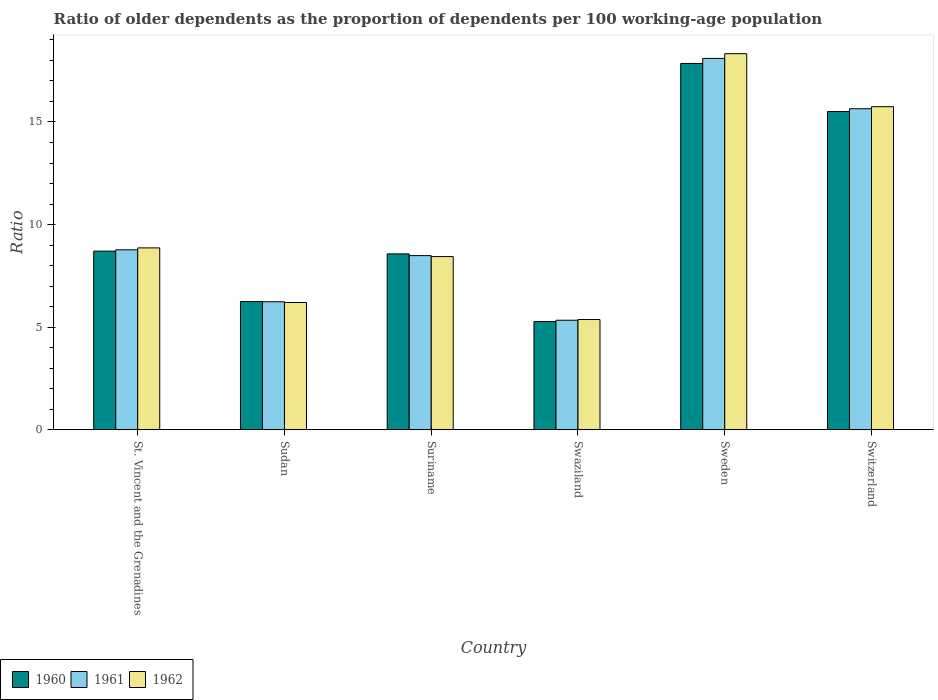Are the number of bars on each tick of the X-axis equal?
Provide a short and direct response. Yes. How many bars are there on the 1st tick from the right?
Your answer should be very brief. 3. What is the label of the 1st group of bars from the left?
Provide a short and direct response. St. Vincent and the Grenadines. In how many cases, is the number of bars for a given country not equal to the number of legend labels?
Make the answer very short. 0. What is the age dependency ratio(old) in 1960 in Suriname?
Your response must be concise. 8.57. Across all countries, what is the maximum age dependency ratio(old) in 1960?
Ensure brevity in your answer.  17.85. Across all countries, what is the minimum age dependency ratio(old) in 1962?
Keep it short and to the point. 5.37. In which country was the age dependency ratio(old) in 1960 minimum?
Your answer should be compact. Swaziland. What is the total age dependency ratio(old) in 1960 in the graph?
Your answer should be very brief. 62.16. What is the difference between the age dependency ratio(old) in 1961 in Suriname and that in Sweden?
Give a very brief answer. -9.61. What is the difference between the age dependency ratio(old) in 1962 in Suriname and the age dependency ratio(old) in 1960 in St. Vincent and the Grenadines?
Provide a succinct answer. -0.27. What is the average age dependency ratio(old) in 1962 per country?
Provide a succinct answer. 10.49. What is the difference between the age dependency ratio(old) of/in 1961 and age dependency ratio(old) of/in 1962 in Sweden?
Offer a very short reply. -0.23. In how many countries, is the age dependency ratio(old) in 1962 greater than 9?
Provide a short and direct response. 2. What is the ratio of the age dependency ratio(old) in 1960 in St. Vincent and the Grenadines to that in Switzerland?
Keep it short and to the point. 0.56. Is the difference between the age dependency ratio(old) in 1961 in St. Vincent and the Grenadines and Sweden greater than the difference between the age dependency ratio(old) in 1962 in St. Vincent and the Grenadines and Sweden?
Give a very brief answer. Yes. What is the difference between the highest and the second highest age dependency ratio(old) in 1962?
Provide a short and direct response. -9.46. What is the difference between the highest and the lowest age dependency ratio(old) in 1960?
Keep it short and to the point. 12.58. Is the sum of the age dependency ratio(old) in 1961 in Sudan and Suriname greater than the maximum age dependency ratio(old) in 1962 across all countries?
Make the answer very short. No. Are all the bars in the graph horizontal?
Your answer should be compact. No. Are the values on the major ticks of Y-axis written in scientific E-notation?
Give a very brief answer. No. Does the graph contain any zero values?
Your answer should be very brief. No. Where does the legend appear in the graph?
Give a very brief answer. Bottom left. How are the legend labels stacked?
Your response must be concise. Horizontal. What is the title of the graph?
Make the answer very short. Ratio of older dependents as the proportion of dependents per 100 working-age population. Does "1977" appear as one of the legend labels in the graph?
Make the answer very short. No. What is the label or title of the Y-axis?
Offer a terse response. Ratio. What is the Ratio of 1960 in St. Vincent and the Grenadines?
Your response must be concise. 8.71. What is the Ratio of 1961 in St. Vincent and the Grenadines?
Keep it short and to the point. 8.77. What is the Ratio of 1962 in St. Vincent and the Grenadines?
Give a very brief answer. 8.86. What is the Ratio of 1960 in Sudan?
Give a very brief answer. 6.25. What is the Ratio of 1961 in Sudan?
Keep it short and to the point. 6.24. What is the Ratio of 1962 in Sudan?
Your answer should be compact. 6.2. What is the Ratio of 1960 in Suriname?
Your answer should be very brief. 8.57. What is the Ratio of 1961 in Suriname?
Offer a very short reply. 8.49. What is the Ratio in 1962 in Suriname?
Make the answer very short. 8.44. What is the Ratio in 1960 in Swaziland?
Keep it short and to the point. 5.28. What is the Ratio of 1961 in Swaziland?
Provide a short and direct response. 5.34. What is the Ratio of 1962 in Swaziland?
Your answer should be compact. 5.37. What is the Ratio in 1960 in Sweden?
Keep it short and to the point. 17.85. What is the Ratio of 1961 in Sweden?
Ensure brevity in your answer.  18.1. What is the Ratio of 1962 in Sweden?
Provide a succinct answer. 18.33. What is the Ratio of 1960 in Switzerland?
Offer a terse response. 15.51. What is the Ratio in 1961 in Switzerland?
Give a very brief answer. 15.64. What is the Ratio of 1962 in Switzerland?
Offer a terse response. 15.74. Across all countries, what is the maximum Ratio of 1960?
Your answer should be compact. 17.85. Across all countries, what is the maximum Ratio of 1961?
Offer a terse response. 18.1. Across all countries, what is the maximum Ratio of 1962?
Your answer should be compact. 18.33. Across all countries, what is the minimum Ratio in 1960?
Provide a short and direct response. 5.28. Across all countries, what is the minimum Ratio in 1961?
Make the answer very short. 5.34. Across all countries, what is the minimum Ratio in 1962?
Your response must be concise. 5.37. What is the total Ratio of 1960 in the graph?
Your answer should be compact. 62.16. What is the total Ratio in 1961 in the graph?
Your answer should be compact. 62.58. What is the total Ratio in 1962 in the graph?
Your response must be concise. 62.95. What is the difference between the Ratio of 1960 in St. Vincent and the Grenadines and that in Sudan?
Provide a succinct answer. 2.46. What is the difference between the Ratio in 1961 in St. Vincent and the Grenadines and that in Sudan?
Your answer should be compact. 2.53. What is the difference between the Ratio in 1962 in St. Vincent and the Grenadines and that in Sudan?
Offer a very short reply. 2.66. What is the difference between the Ratio of 1960 in St. Vincent and the Grenadines and that in Suriname?
Your response must be concise. 0.14. What is the difference between the Ratio in 1961 in St. Vincent and the Grenadines and that in Suriname?
Offer a terse response. 0.28. What is the difference between the Ratio in 1962 in St. Vincent and the Grenadines and that in Suriname?
Provide a short and direct response. 0.42. What is the difference between the Ratio in 1960 in St. Vincent and the Grenadines and that in Swaziland?
Your answer should be very brief. 3.43. What is the difference between the Ratio of 1961 in St. Vincent and the Grenadines and that in Swaziland?
Provide a succinct answer. 3.43. What is the difference between the Ratio of 1962 in St. Vincent and the Grenadines and that in Swaziland?
Provide a succinct answer. 3.49. What is the difference between the Ratio of 1960 in St. Vincent and the Grenadines and that in Sweden?
Offer a very short reply. -9.14. What is the difference between the Ratio in 1961 in St. Vincent and the Grenadines and that in Sweden?
Your answer should be compact. -9.33. What is the difference between the Ratio in 1962 in St. Vincent and the Grenadines and that in Sweden?
Keep it short and to the point. -9.46. What is the difference between the Ratio in 1960 in St. Vincent and the Grenadines and that in Switzerland?
Your response must be concise. -6.8. What is the difference between the Ratio of 1961 in St. Vincent and the Grenadines and that in Switzerland?
Offer a terse response. -6.87. What is the difference between the Ratio of 1962 in St. Vincent and the Grenadines and that in Switzerland?
Give a very brief answer. -6.88. What is the difference between the Ratio of 1960 in Sudan and that in Suriname?
Ensure brevity in your answer.  -2.32. What is the difference between the Ratio of 1961 in Sudan and that in Suriname?
Your answer should be very brief. -2.25. What is the difference between the Ratio of 1962 in Sudan and that in Suriname?
Offer a very short reply. -2.24. What is the difference between the Ratio in 1960 in Sudan and that in Swaziland?
Provide a succinct answer. 0.97. What is the difference between the Ratio in 1961 in Sudan and that in Swaziland?
Make the answer very short. 0.9. What is the difference between the Ratio of 1962 in Sudan and that in Swaziland?
Offer a very short reply. 0.83. What is the difference between the Ratio in 1960 in Sudan and that in Sweden?
Your response must be concise. -11.6. What is the difference between the Ratio in 1961 in Sudan and that in Sweden?
Provide a short and direct response. -11.86. What is the difference between the Ratio in 1962 in Sudan and that in Sweden?
Provide a succinct answer. -12.12. What is the difference between the Ratio of 1960 in Sudan and that in Switzerland?
Provide a succinct answer. -9.26. What is the difference between the Ratio of 1961 in Sudan and that in Switzerland?
Your answer should be very brief. -9.41. What is the difference between the Ratio of 1962 in Sudan and that in Switzerland?
Offer a very short reply. -9.54. What is the difference between the Ratio in 1960 in Suriname and that in Swaziland?
Ensure brevity in your answer.  3.3. What is the difference between the Ratio of 1961 in Suriname and that in Swaziland?
Your response must be concise. 3.15. What is the difference between the Ratio in 1962 in Suriname and that in Swaziland?
Make the answer very short. 3.07. What is the difference between the Ratio of 1960 in Suriname and that in Sweden?
Offer a terse response. -9.28. What is the difference between the Ratio in 1961 in Suriname and that in Sweden?
Ensure brevity in your answer.  -9.61. What is the difference between the Ratio of 1962 in Suriname and that in Sweden?
Give a very brief answer. -9.89. What is the difference between the Ratio of 1960 in Suriname and that in Switzerland?
Provide a succinct answer. -6.94. What is the difference between the Ratio of 1961 in Suriname and that in Switzerland?
Give a very brief answer. -7.16. What is the difference between the Ratio of 1962 in Suriname and that in Switzerland?
Make the answer very short. -7.3. What is the difference between the Ratio of 1960 in Swaziland and that in Sweden?
Make the answer very short. -12.58. What is the difference between the Ratio of 1961 in Swaziland and that in Sweden?
Give a very brief answer. -12.76. What is the difference between the Ratio in 1962 in Swaziland and that in Sweden?
Offer a terse response. -12.95. What is the difference between the Ratio of 1960 in Swaziland and that in Switzerland?
Give a very brief answer. -10.23. What is the difference between the Ratio in 1961 in Swaziland and that in Switzerland?
Ensure brevity in your answer.  -10.31. What is the difference between the Ratio in 1962 in Swaziland and that in Switzerland?
Your response must be concise. -10.37. What is the difference between the Ratio in 1960 in Sweden and that in Switzerland?
Provide a succinct answer. 2.34. What is the difference between the Ratio of 1961 in Sweden and that in Switzerland?
Provide a short and direct response. 2.45. What is the difference between the Ratio of 1962 in Sweden and that in Switzerland?
Provide a succinct answer. 2.58. What is the difference between the Ratio of 1960 in St. Vincent and the Grenadines and the Ratio of 1961 in Sudan?
Make the answer very short. 2.47. What is the difference between the Ratio of 1960 in St. Vincent and the Grenadines and the Ratio of 1962 in Sudan?
Give a very brief answer. 2.5. What is the difference between the Ratio in 1961 in St. Vincent and the Grenadines and the Ratio in 1962 in Sudan?
Offer a very short reply. 2.57. What is the difference between the Ratio of 1960 in St. Vincent and the Grenadines and the Ratio of 1961 in Suriname?
Provide a short and direct response. 0.22. What is the difference between the Ratio in 1960 in St. Vincent and the Grenadines and the Ratio in 1962 in Suriname?
Keep it short and to the point. 0.27. What is the difference between the Ratio of 1961 in St. Vincent and the Grenadines and the Ratio of 1962 in Suriname?
Ensure brevity in your answer.  0.33. What is the difference between the Ratio of 1960 in St. Vincent and the Grenadines and the Ratio of 1961 in Swaziland?
Keep it short and to the point. 3.37. What is the difference between the Ratio of 1960 in St. Vincent and the Grenadines and the Ratio of 1962 in Swaziland?
Provide a succinct answer. 3.33. What is the difference between the Ratio in 1961 in St. Vincent and the Grenadines and the Ratio in 1962 in Swaziland?
Give a very brief answer. 3.4. What is the difference between the Ratio in 1960 in St. Vincent and the Grenadines and the Ratio in 1961 in Sweden?
Your answer should be very brief. -9.39. What is the difference between the Ratio of 1960 in St. Vincent and the Grenadines and the Ratio of 1962 in Sweden?
Provide a succinct answer. -9.62. What is the difference between the Ratio in 1961 in St. Vincent and the Grenadines and the Ratio in 1962 in Sweden?
Keep it short and to the point. -9.56. What is the difference between the Ratio in 1960 in St. Vincent and the Grenadines and the Ratio in 1961 in Switzerland?
Your response must be concise. -6.94. What is the difference between the Ratio of 1960 in St. Vincent and the Grenadines and the Ratio of 1962 in Switzerland?
Ensure brevity in your answer.  -7.04. What is the difference between the Ratio of 1961 in St. Vincent and the Grenadines and the Ratio of 1962 in Switzerland?
Provide a short and direct response. -6.97. What is the difference between the Ratio in 1960 in Sudan and the Ratio in 1961 in Suriname?
Ensure brevity in your answer.  -2.24. What is the difference between the Ratio of 1960 in Sudan and the Ratio of 1962 in Suriname?
Your answer should be compact. -2.19. What is the difference between the Ratio in 1961 in Sudan and the Ratio in 1962 in Suriname?
Your response must be concise. -2.2. What is the difference between the Ratio in 1960 in Sudan and the Ratio in 1961 in Swaziland?
Provide a short and direct response. 0.91. What is the difference between the Ratio in 1960 in Sudan and the Ratio in 1962 in Swaziland?
Keep it short and to the point. 0.88. What is the difference between the Ratio of 1961 in Sudan and the Ratio of 1962 in Swaziland?
Ensure brevity in your answer.  0.86. What is the difference between the Ratio of 1960 in Sudan and the Ratio of 1961 in Sweden?
Your response must be concise. -11.85. What is the difference between the Ratio of 1960 in Sudan and the Ratio of 1962 in Sweden?
Make the answer very short. -12.08. What is the difference between the Ratio of 1961 in Sudan and the Ratio of 1962 in Sweden?
Ensure brevity in your answer.  -12.09. What is the difference between the Ratio in 1960 in Sudan and the Ratio in 1961 in Switzerland?
Make the answer very short. -9.39. What is the difference between the Ratio of 1960 in Sudan and the Ratio of 1962 in Switzerland?
Ensure brevity in your answer.  -9.5. What is the difference between the Ratio of 1961 in Sudan and the Ratio of 1962 in Switzerland?
Keep it short and to the point. -9.51. What is the difference between the Ratio in 1960 in Suriname and the Ratio in 1961 in Swaziland?
Give a very brief answer. 3.23. What is the difference between the Ratio of 1960 in Suriname and the Ratio of 1962 in Swaziland?
Provide a short and direct response. 3.2. What is the difference between the Ratio in 1961 in Suriname and the Ratio in 1962 in Swaziland?
Make the answer very short. 3.11. What is the difference between the Ratio in 1960 in Suriname and the Ratio in 1961 in Sweden?
Give a very brief answer. -9.53. What is the difference between the Ratio in 1960 in Suriname and the Ratio in 1962 in Sweden?
Give a very brief answer. -9.76. What is the difference between the Ratio in 1961 in Suriname and the Ratio in 1962 in Sweden?
Provide a succinct answer. -9.84. What is the difference between the Ratio in 1960 in Suriname and the Ratio in 1961 in Switzerland?
Make the answer very short. -7.07. What is the difference between the Ratio in 1960 in Suriname and the Ratio in 1962 in Switzerland?
Keep it short and to the point. -7.17. What is the difference between the Ratio in 1961 in Suriname and the Ratio in 1962 in Switzerland?
Your answer should be compact. -7.26. What is the difference between the Ratio of 1960 in Swaziland and the Ratio of 1961 in Sweden?
Ensure brevity in your answer.  -12.82. What is the difference between the Ratio of 1960 in Swaziland and the Ratio of 1962 in Sweden?
Your response must be concise. -13.05. What is the difference between the Ratio in 1961 in Swaziland and the Ratio in 1962 in Sweden?
Ensure brevity in your answer.  -12.99. What is the difference between the Ratio of 1960 in Swaziland and the Ratio of 1961 in Switzerland?
Offer a very short reply. -10.37. What is the difference between the Ratio in 1960 in Swaziland and the Ratio in 1962 in Switzerland?
Your answer should be very brief. -10.47. What is the difference between the Ratio of 1961 in Swaziland and the Ratio of 1962 in Switzerland?
Your answer should be compact. -10.41. What is the difference between the Ratio of 1960 in Sweden and the Ratio of 1961 in Switzerland?
Ensure brevity in your answer.  2.21. What is the difference between the Ratio in 1960 in Sweden and the Ratio in 1962 in Switzerland?
Make the answer very short. 2.11. What is the difference between the Ratio in 1961 in Sweden and the Ratio in 1962 in Switzerland?
Make the answer very short. 2.35. What is the average Ratio of 1960 per country?
Offer a terse response. 10.36. What is the average Ratio of 1961 per country?
Give a very brief answer. 10.43. What is the average Ratio in 1962 per country?
Offer a terse response. 10.49. What is the difference between the Ratio of 1960 and Ratio of 1961 in St. Vincent and the Grenadines?
Offer a terse response. -0.06. What is the difference between the Ratio of 1960 and Ratio of 1962 in St. Vincent and the Grenadines?
Provide a succinct answer. -0.16. What is the difference between the Ratio in 1961 and Ratio in 1962 in St. Vincent and the Grenadines?
Provide a short and direct response. -0.09. What is the difference between the Ratio of 1960 and Ratio of 1961 in Sudan?
Keep it short and to the point. 0.01. What is the difference between the Ratio in 1960 and Ratio in 1962 in Sudan?
Keep it short and to the point. 0.05. What is the difference between the Ratio in 1961 and Ratio in 1962 in Sudan?
Your response must be concise. 0.04. What is the difference between the Ratio of 1960 and Ratio of 1961 in Suriname?
Make the answer very short. 0.08. What is the difference between the Ratio of 1960 and Ratio of 1962 in Suriname?
Ensure brevity in your answer.  0.13. What is the difference between the Ratio of 1961 and Ratio of 1962 in Suriname?
Keep it short and to the point. 0.05. What is the difference between the Ratio in 1960 and Ratio in 1961 in Swaziland?
Give a very brief answer. -0.06. What is the difference between the Ratio in 1960 and Ratio in 1962 in Swaziland?
Provide a succinct answer. -0.1. What is the difference between the Ratio of 1961 and Ratio of 1962 in Swaziland?
Your answer should be very brief. -0.04. What is the difference between the Ratio of 1960 and Ratio of 1961 in Sweden?
Your answer should be very brief. -0.25. What is the difference between the Ratio in 1960 and Ratio in 1962 in Sweden?
Provide a short and direct response. -0.48. What is the difference between the Ratio of 1961 and Ratio of 1962 in Sweden?
Your response must be concise. -0.23. What is the difference between the Ratio of 1960 and Ratio of 1961 in Switzerland?
Your response must be concise. -0.14. What is the difference between the Ratio in 1960 and Ratio in 1962 in Switzerland?
Offer a very short reply. -0.24. What is the difference between the Ratio in 1961 and Ratio in 1962 in Switzerland?
Your answer should be compact. -0.1. What is the ratio of the Ratio of 1960 in St. Vincent and the Grenadines to that in Sudan?
Offer a terse response. 1.39. What is the ratio of the Ratio of 1961 in St. Vincent and the Grenadines to that in Sudan?
Your response must be concise. 1.41. What is the ratio of the Ratio of 1962 in St. Vincent and the Grenadines to that in Sudan?
Keep it short and to the point. 1.43. What is the ratio of the Ratio in 1960 in St. Vincent and the Grenadines to that in Suriname?
Offer a terse response. 1.02. What is the ratio of the Ratio of 1961 in St. Vincent and the Grenadines to that in Suriname?
Your answer should be very brief. 1.03. What is the ratio of the Ratio in 1962 in St. Vincent and the Grenadines to that in Suriname?
Your answer should be very brief. 1.05. What is the ratio of the Ratio of 1960 in St. Vincent and the Grenadines to that in Swaziland?
Offer a terse response. 1.65. What is the ratio of the Ratio in 1961 in St. Vincent and the Grenadines to that in Swaziland?
Your answer should be very brief. 1.64. What is the ratio of the Ratio of 1962 in St. Vincent and the Grenadines to that in Swaziland?
Give a very brief answer. 1.65. What is the ratio of the Ratio of 1960 in St. Vincent and the Grenadines to that in Sweden?
Make the answer very short. 0.49. What is the ratio of the Ratio of 1961 in St. Vincent and the Grenadines to that in Sweden?
Keep it short and to the point. 0.48. What is the ratio of the Ratio in 1962 in St. Vincent and the Grenadines to that in Sweden?
Offer a very short reply. 0.48. What is the ratio of the Ratio of 1960 in St. Vincent and the Grenadines to that in Switzerland?
Give a very brief answer. 0.56. What is the ratio of the Ratio of 1961 in St. Vincent and the Grenadines to that in Switzerland?
Your response must be concise. 0.56. What is the ratio of the Ratio of 1962 in St. Vincent and the Grenadines to that in Switzerland?
Your answer should be compact. 0.56. What is the ratio of the Ratio of 1960 in Sudan to that in Suriname?
Provide a succinct answer. 0.73. What is the ratio of the Ratio in 1961 in Sudan to that in Suriname?
Your response must be concise. 0.73. What is the ratio of the Ratio in 1962 in Sudan to that in Suriname?
Offer a very short reply. 0.73. What is the ratio of the Ratio of 1960 in Sudan to that in Swaziland?
Give a very brief answer. 1.18. What is the ratio of the Ratio in 1961 in Sudan to that in Swaziland?
Offer a terse response. 1.17. What is the ratio of the Ratio in 1962 in Sudan to that in Swaziland?
Your response must be concise. 1.15. What is the ratio of the Ratio of 1960 in Sudan to that in Sweden?
Your answer should be very brief. 0.35. What is the ratio of the Ratio of 1961 in Sudan to that in Sweden?
Your response must be concise. 0.34. What is the ratio of the Ratio of 1962 in Sudan to that in Sweden?
Provide a short and direct response. 0.34. What is the ratio of the Ratio in 1960 in Sudan to that in Switzerland?
Offer a terse response. 0.4. What is the ratio of the Ratio in 1961 in Sudan to that in Switzerland?
Make the answer very short. 0.4. What is the ratio of the Ratio of 1962 in Sudan to that in Switzerland?
Your answer should be very brief. 0.39. What is the ratio of the Ratio in 1960 in Suriname to that in Swaziland?
Your response must be concise. 1.62. What is the ratio of the Ratio of 1961 in Suriname to that in Swaziland?
Keep it short and to the point. 1.59. What is the ratio of the Ratio of 1962 in Suriname to that in Swaziland?
Offer a very short reply. 1.57. What is the ratio of the Ratio in 1960 in Suriname to that in Sweden?
Offer a terse response. 0.48. What is the ratio of the Ratio of 1961 in Suriname to that in Sweden?
Your response must be concise. 0.47. What is the ratio of the Ratio in 1962 in Suriname to that in Sweden?
Offer a terse response. 0.46. What is the ratio of the Ratio in 1960 in Suriname to that in Switzerland?
Offer a terse response. 0.55. What is the ratio of the Ratio of 1961 in Suriname to that in Switzerland?
Offer a terse response. 0.54. What is the ratio of the Ratio in 1962 in Suriname to that in Switzerland?
Your answer should be compact. 0.54. What is the ratio of the Ratio of 1960 in Swaziland to that in Sweden?
Keep it short and to the point. 0.3. What is the ratio of the Ratio in 1961 in Swaziland to that in Sweden?
Your answer should be compact. 0.29. What is the ratio of the Ratio of 1962 in Swaziland to that in Sweden?
Your answer should be compact. 0.29. What is the ratio of the Ratio in 1960 in Swaziland to that in Switzerland?
Ensure brevity in your answer.  0.34. What is the ratio of the Ratio in 1961 in Swaziland to that in Switzerland?
Your response must be concise. 0.34. What is the ratio of the Ratio in 1962 in Swaziland to that in Switzerland?
Your answer should be compact. 0.34. What is the ratio of the Ratio in 1960 in Sweden to that in Switzerland?
Provide a short and direct response. 1.15. What is the ratio of the Ratio of 1961 in Sweden to that in Switzerland?
Make the answer very short. 1.16. What is the ratio of the Ratio of 1962 in Sweden to that in Switzerland?
Give a very brief answer. 1.16. What is the difference between the highest and the second highest Ratio of 1960?
Offer a terse response. 2.34. What is the difference between the highest and the second highest Ratio in 1961?
Your answer should be compact. 2.45. What is the difference between the highest and the second highest Ratio of 1962?
Give a very brief answer. 2.58. What is the difference between the highest and the lowest Ratio of 1960?
Make the answer very short. 12.58. What is the difference between the highest and the lowest Ratio of 1961?
Your answer should be very brief. 12.76. What is the difference between the highest and the lowest Ratio in 1962?
Give a very brief answer. 12.95. 